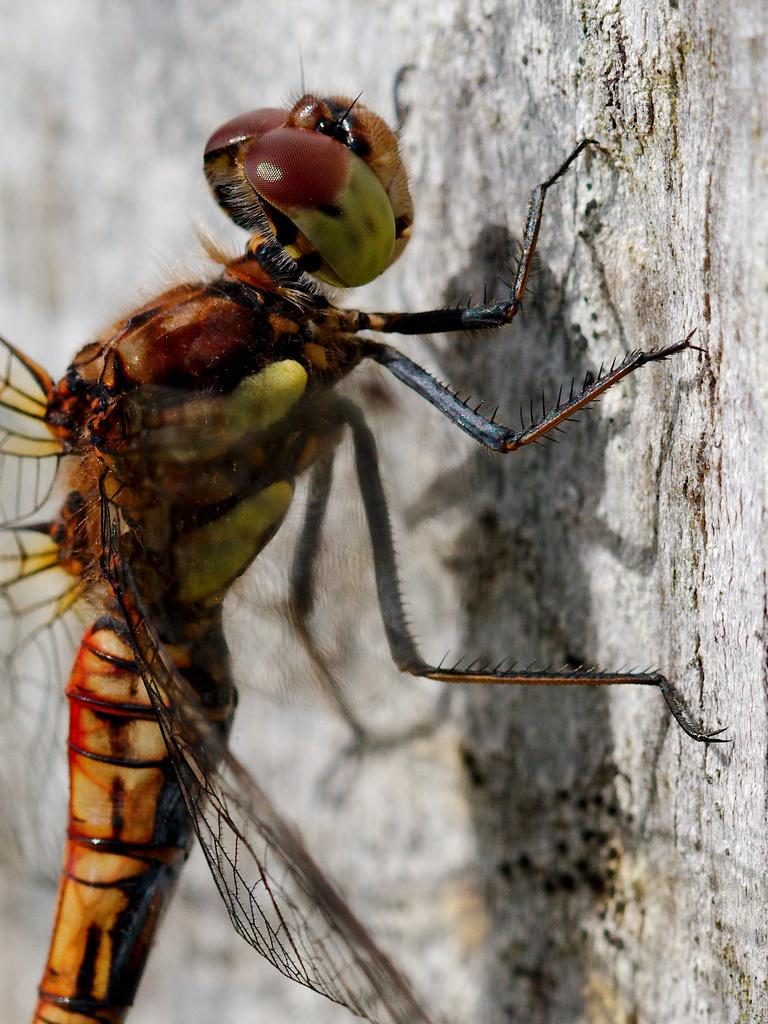What type of insect is present in the image? There is a dragonfly in the image. What type of board can be seen being carried by the dragonfly in the image? There is no board present in the image, as it features a dragonfly and no other objects or elements. 